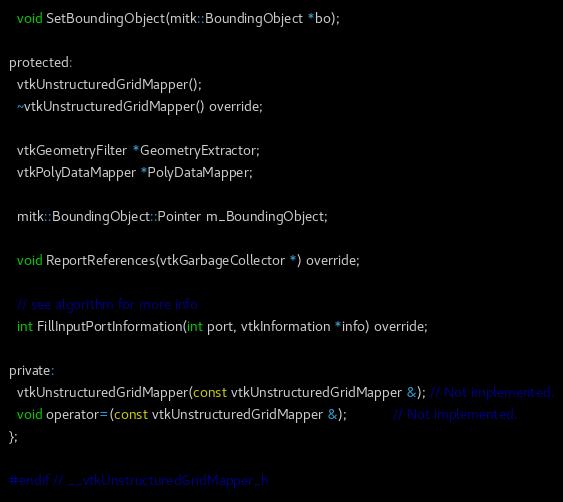<code> <loc_0><loc_0><loc_500><loc_500><_C_>
  void SetBoundingObject(mitk::BoundingObject *bo);

protected:
  vtkUnstructuredGridMapper();
  ~vtkUnstructuredGridMapper() override;

  vtkGeometryFilter *GeometryExtractor;
  vtkPolyDataMapper *PolyDataMapper;

  mitk::BoundingObject::Pointer m_BoundingObject;

  void ReportReferences(vtkGarbageCollector *) override;

  // see algorithm for more info
  int FillInputPortInformation(int port, vtkInformation *info) override;

private:
  vtkUnstructuredGridMapper(const vtkUnstructuredGridMapper &); // Not implemented.
  void operator=(const vtkUnstructuredGridMapper &);            // Not implemented.
};

#endif // __vtkUnstructuredGridMapper_h
</code> 